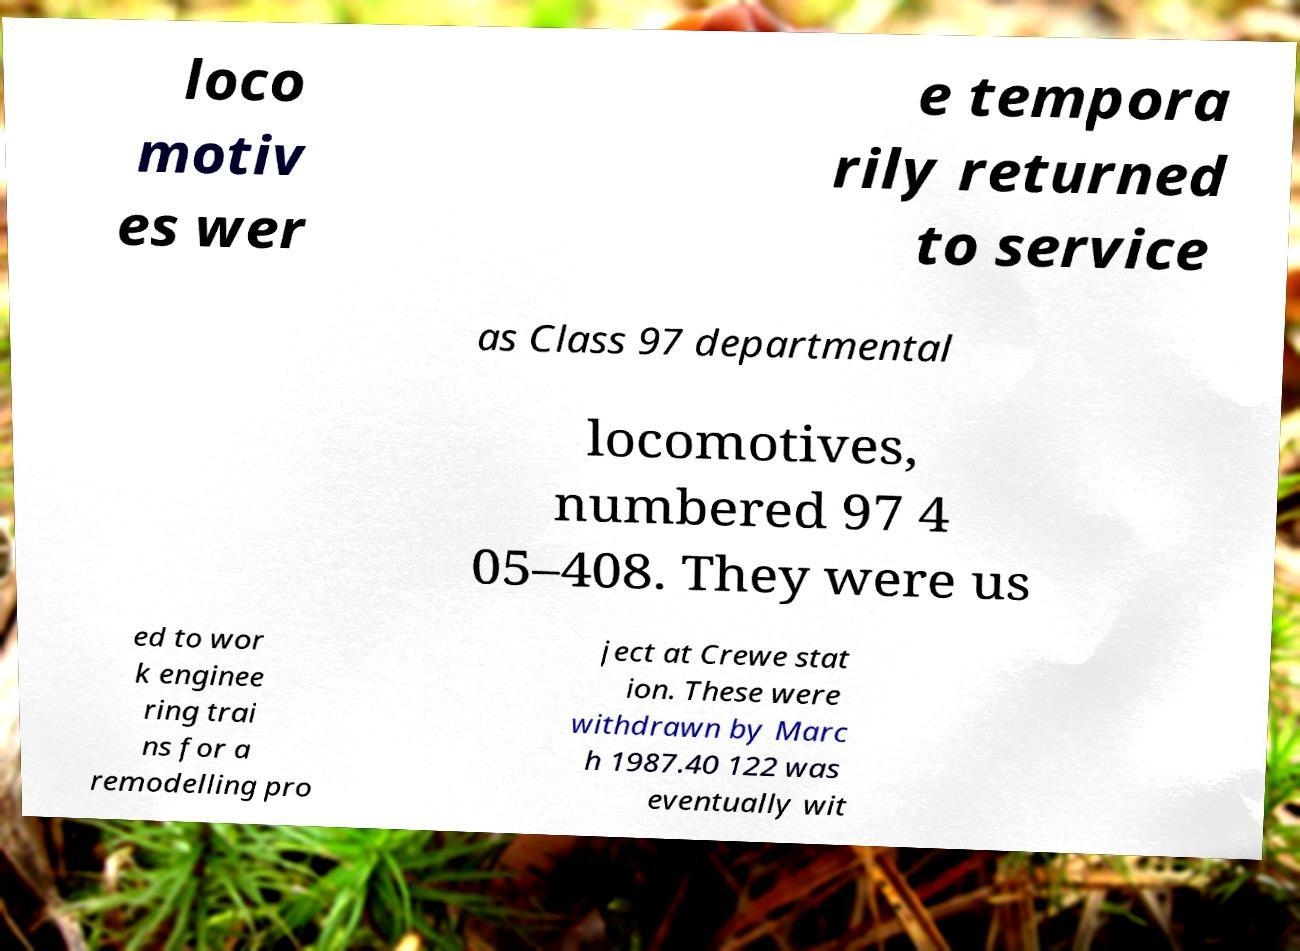For documentation purposes, I need the text within this image transcribed. Could you provide that? loco motiv es wer e tempora rily returned to service as Class 97 departmental locomotives, numbered 97 4 05–408. They were us ed to wor k enginee ring trai ns for a remodelling pro ject at Crewe stat ion. These were withdrawn by Marc h 1987.40 122 was eventually wit 